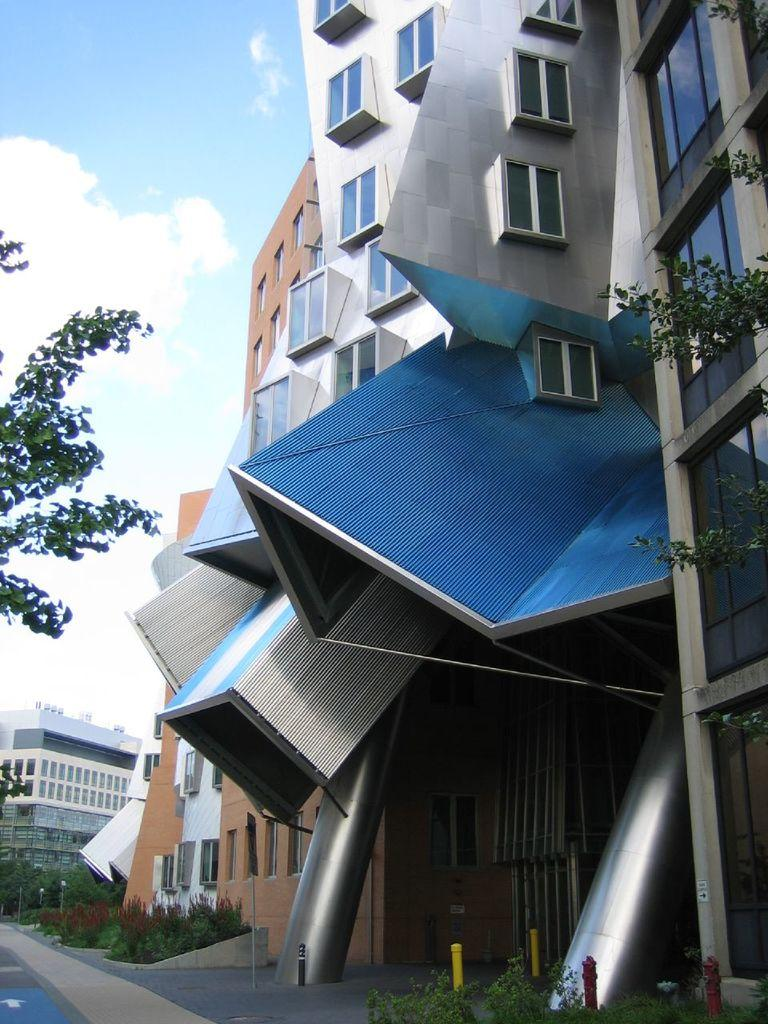What type of structures are located on the right side of the image? There are big buildings on the right side of the image. What type of vegetation can be seen in the image? There are trees in the image. What is the condition of the sky in the image? The sky is cloudy in the image. What type of idea is being expressed by the trees in the image? There is no indication of an idea being expressed by the trees in the image; they are simply vegetation. Can you see a turkey in the image? There is no turkey present in the image. 